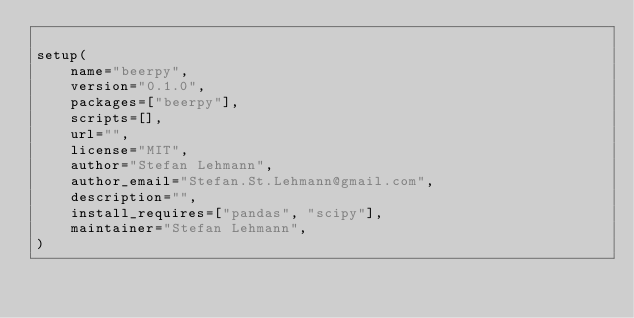<code> <loc_0><loc_0><loc_500><loc_500><_Python_>
setup(
    name="beerpy",
    version="0.1.0",
    packages=["beerpy"],
    scripts=[],
    url="",
    license="MIT",
    author="Stefan Lehmann",
    author_email="Stefan.St.Lehmann@gmail.com",
    description="",
    install_requires=["pandas", "scipy"],
    maintainer="Stefan Lehmann",
)
</code> 